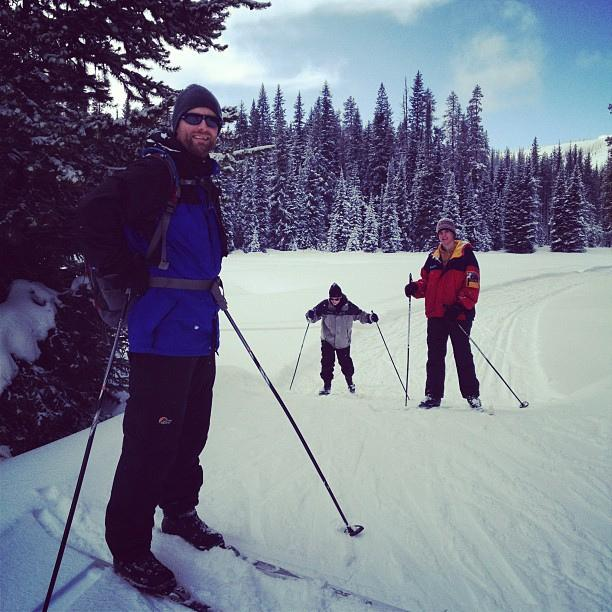Who is skiing with the man in front?

Choices:
A) his grandmother
B) no one
C) someone unseen
D) those behind those behind 